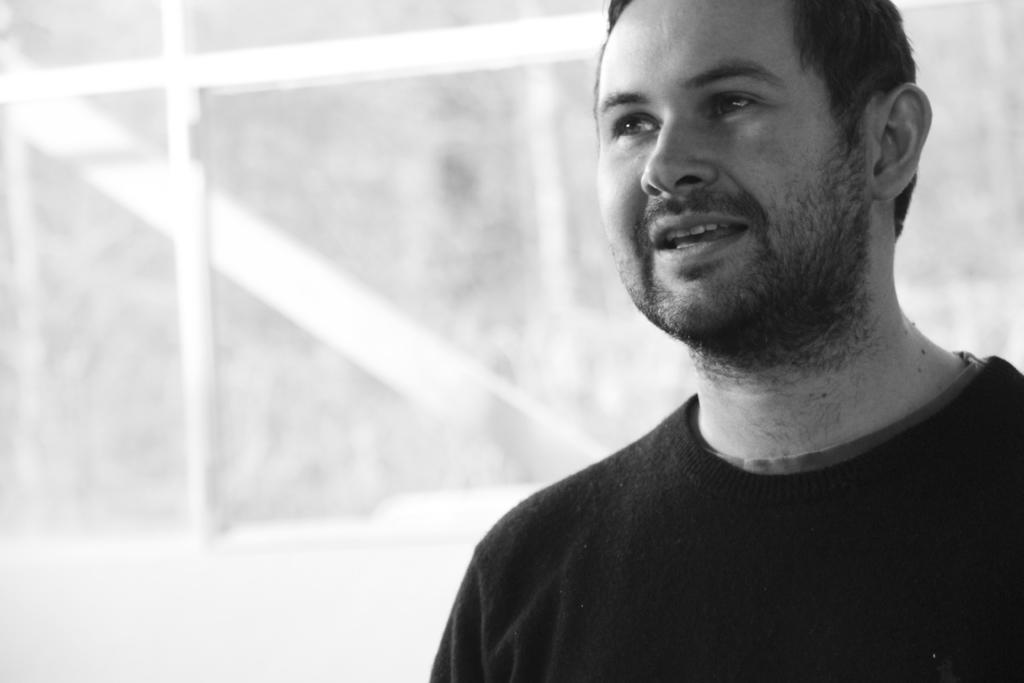What is the color scheme of the image? The image is black and white. Where is the man located in the image? The man is on the right side of the image. What can be seen in the background of the image? There is a window in the background of the image. What is at the bottom of the image? There is a wall at the bottom of the image. How much debt does the man owe in the image? There is no information about debt in the image, as it is a black and white image of a man and a window. Is there a slave present in the image? There is no mention of a slave or any indication of slavery in the image. 